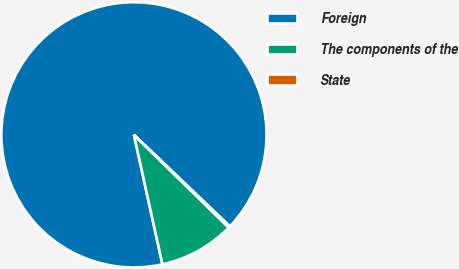Convert chart. <chart><loc_0><loc_0><loc_500><loc_500><pie_chart><fcel>Foreign<fcel>The components of the<fcel>State<nl><fcel>90.58%<fcel>9.23%<fcel>0.19%<nl></chart> 